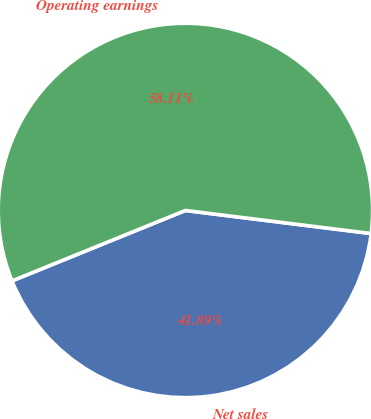<chart> <loc_0><loc_0><loc_500><loc_500><pie_chart><fcel>Net sales<fcel>Operating earnings<nl><fcel>41.89%<fcel>58.11%<nl></chart> 